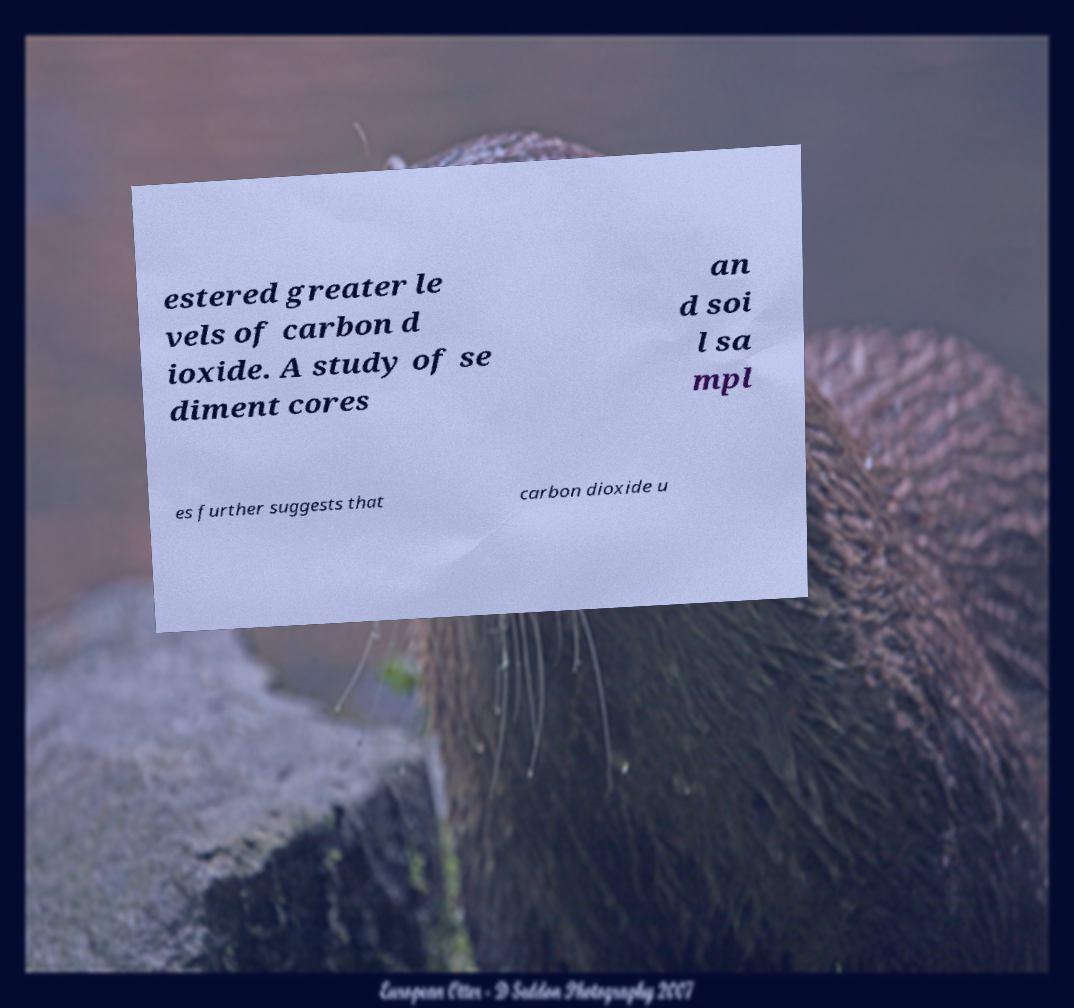Could you assist in decoding the text presented in this image and type it out clearly? estered greater le vels of carbon d ioxide. A study of se diment cores an d soi l sa mpl es further suggests that carbon dioxide u 